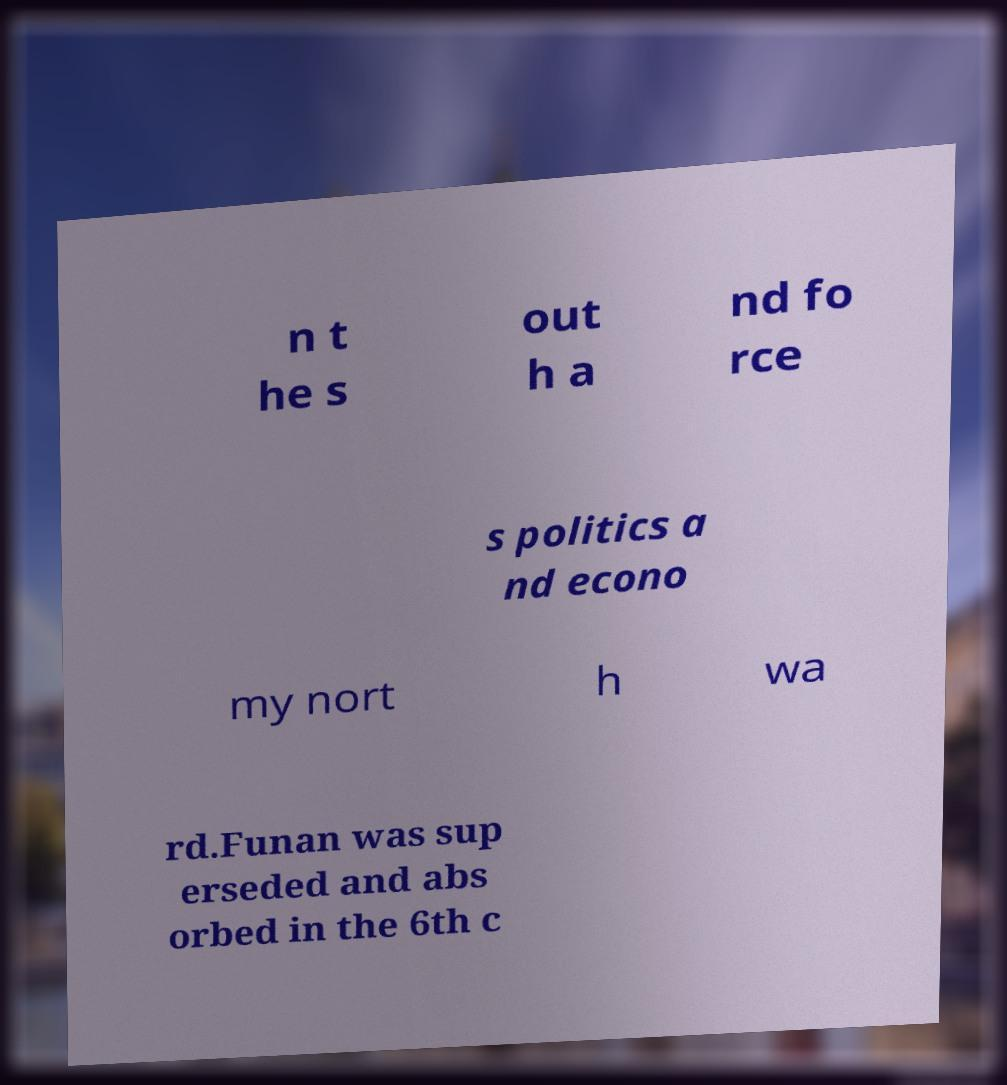There's text embedded in this image that I need extracted. Can you transcribe it verbatim? n t he s out h a nd fo rce s politics a nd econo my nort h wa rd.Funan was sup erseded and abs orbed in the 6th c 